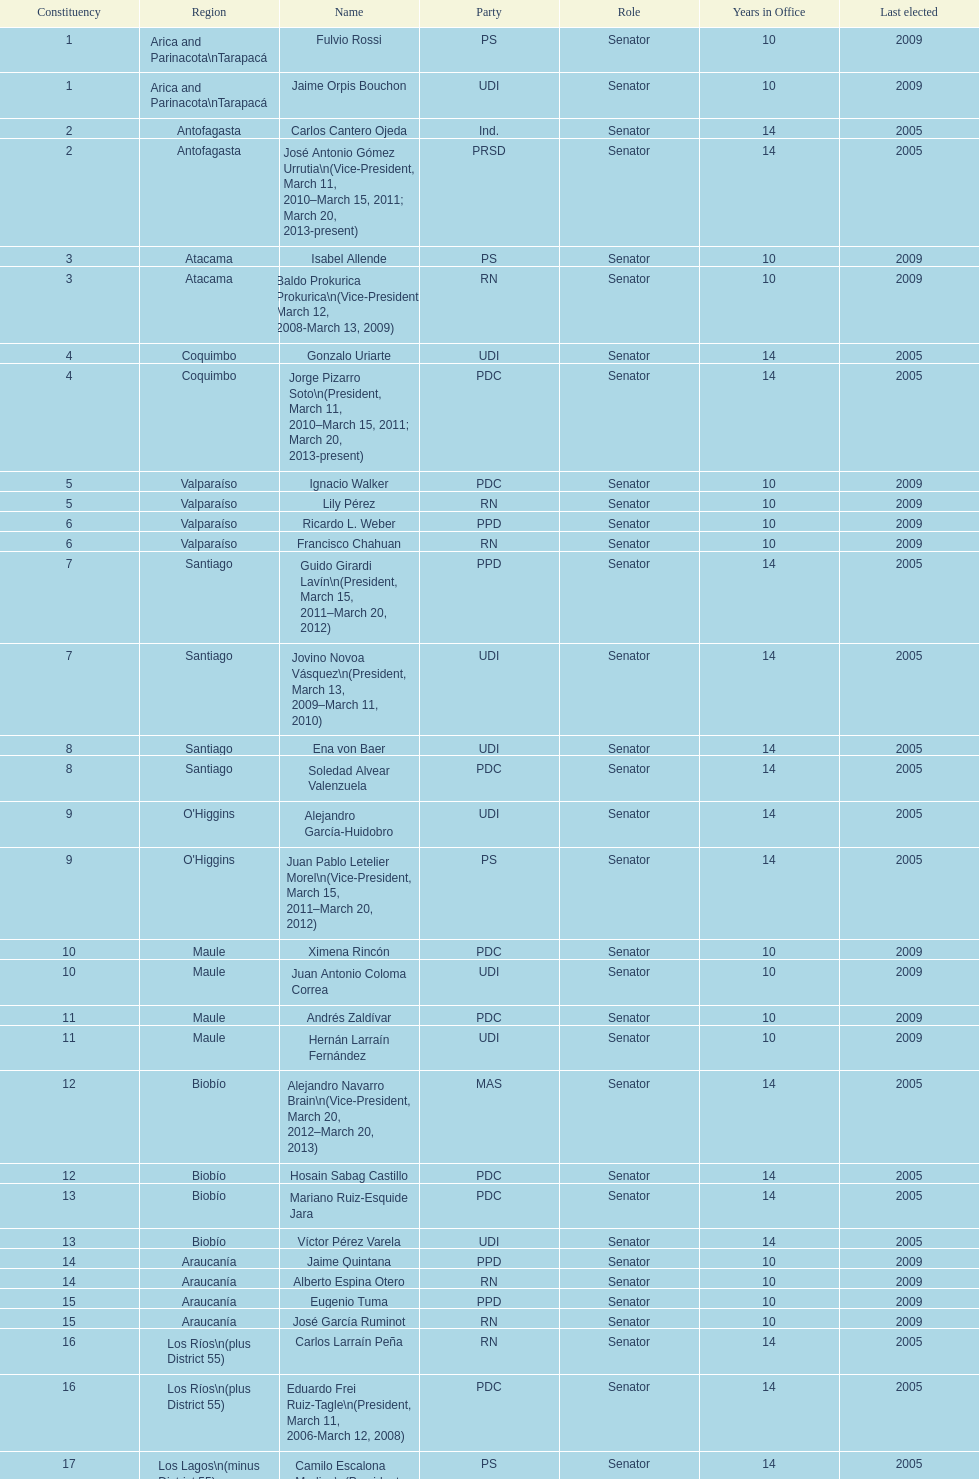What is the total number of constituencies? 19. 